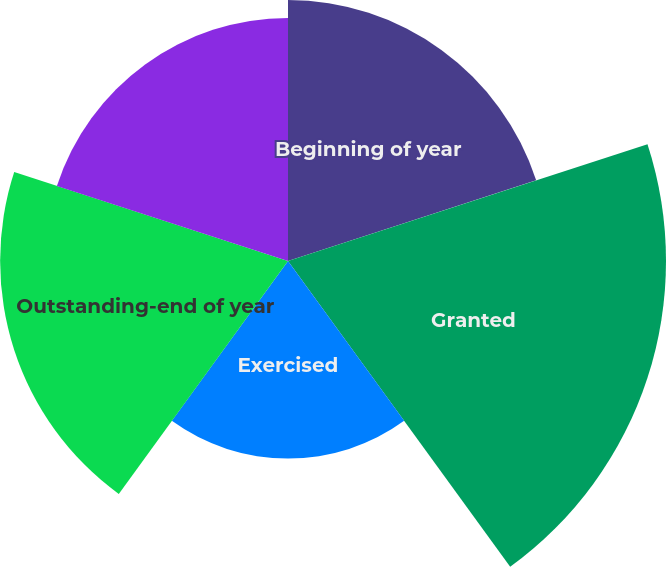Convert chart to OTSL. <chart><loc_0><loc_0><loc_500><loc_500><pie_chart><fcel>Beginning of year<fcel>Granted<fcel>Exercised<fcel>Outstanding-end of year<fcel>Exercisable-end of year<nl><fcel>19.08%<fcel>27.64%<fcel>14.45%<fcel>21.05%<fcel>17.77%<nl></chart> 